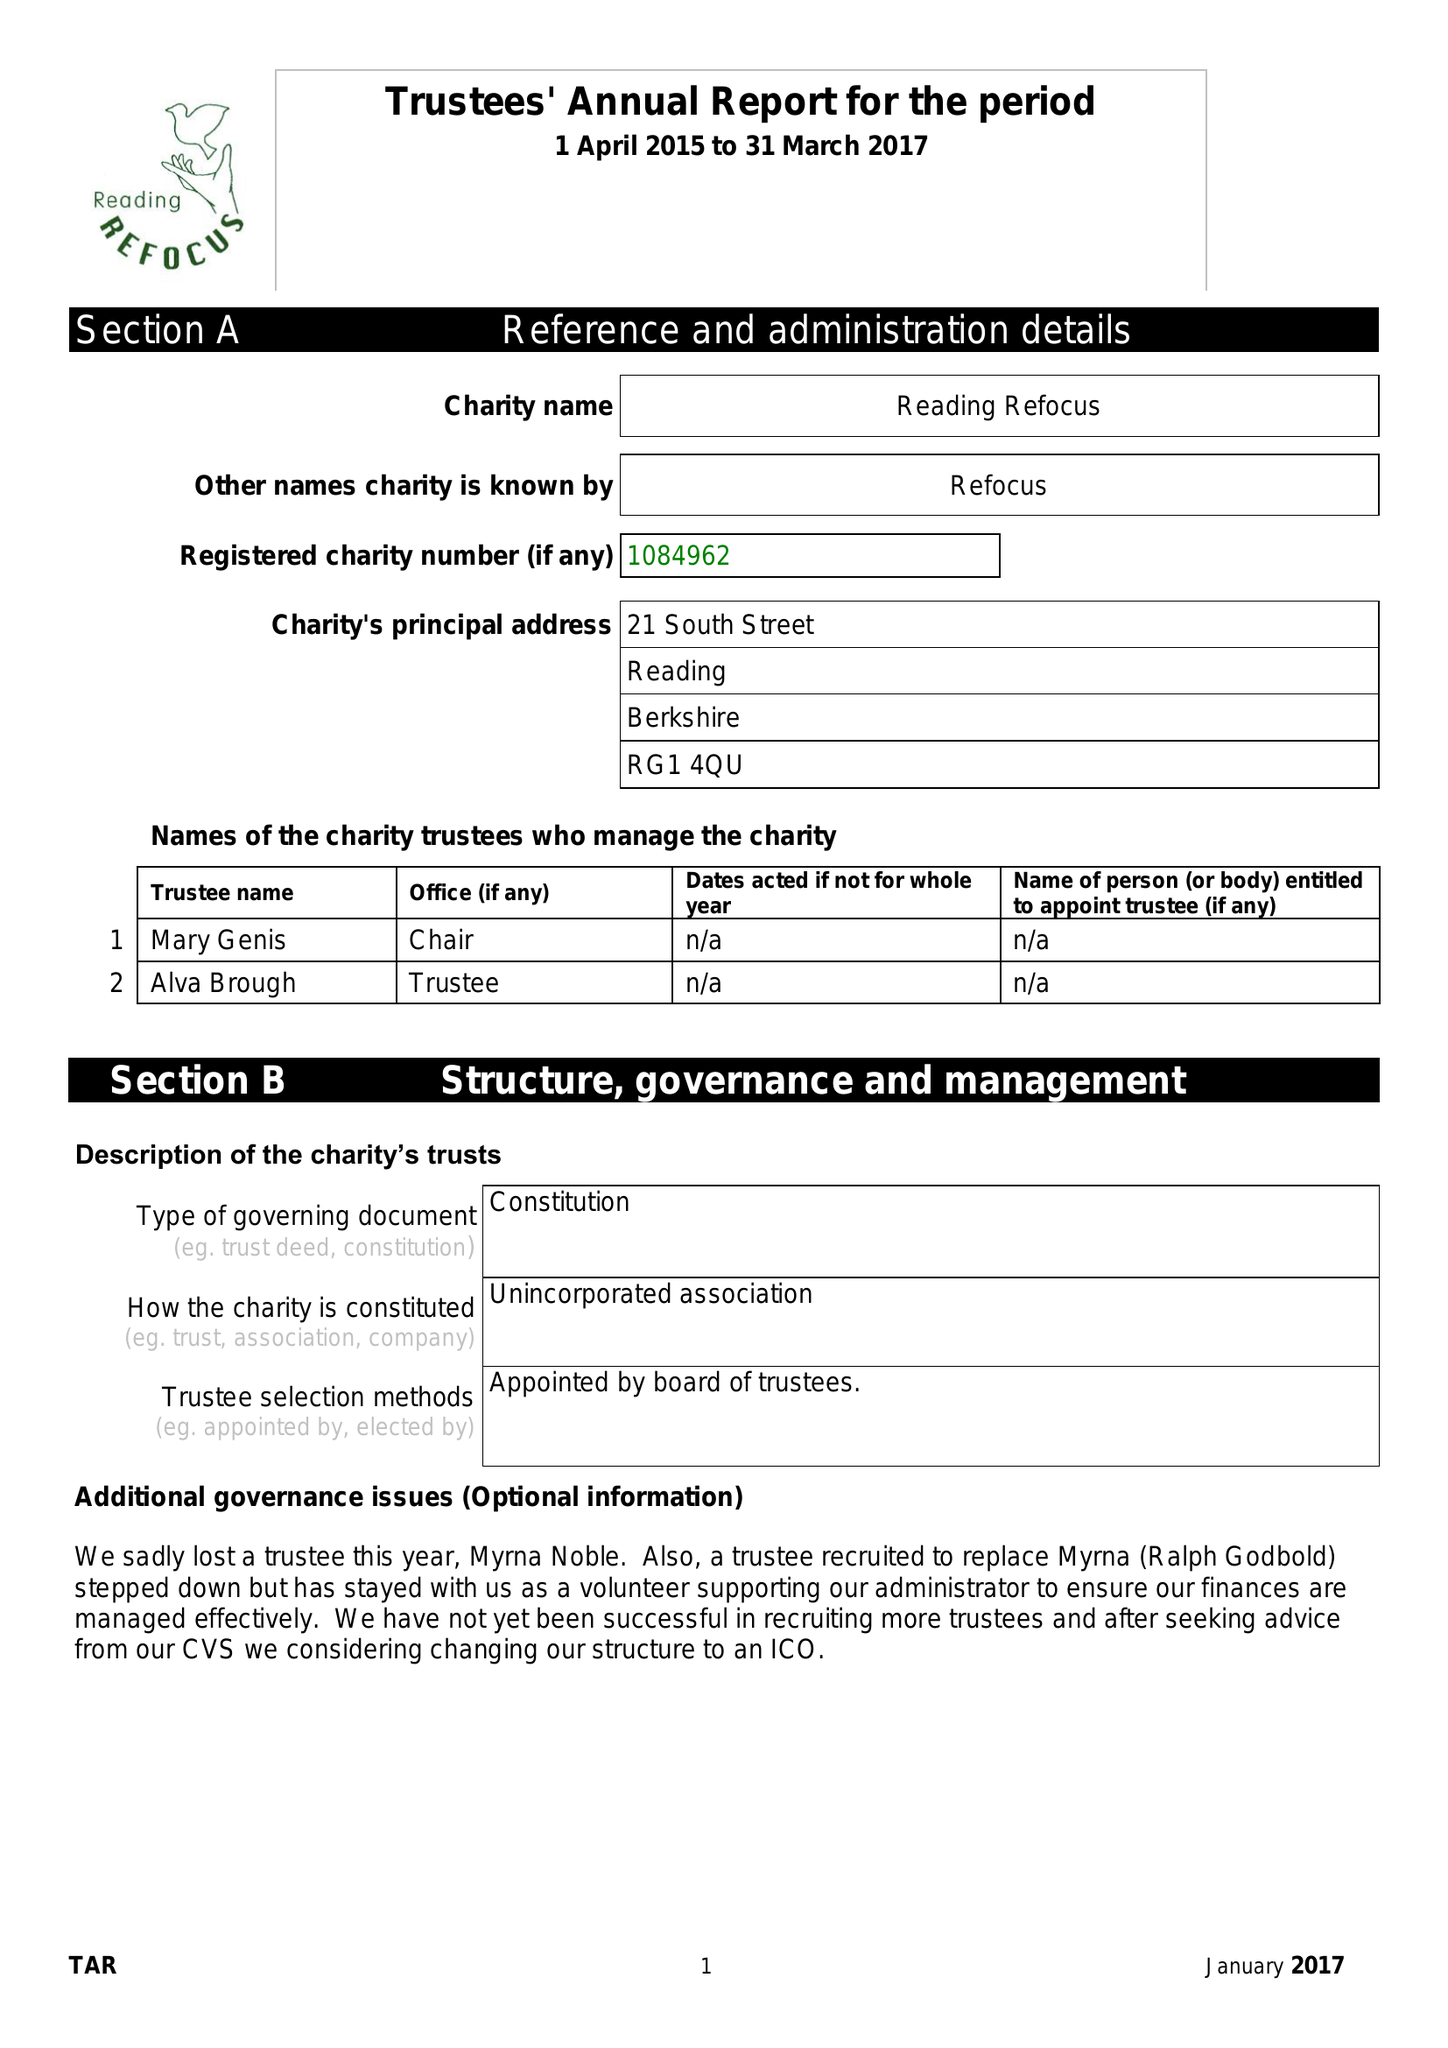What is the value for the charity_name?
Answer the question using a single word or phrase. Reading Refocus 